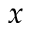Convert formula to latex. <formula><loc_0><loc_0><loc_500><loc_500>x</formula> 